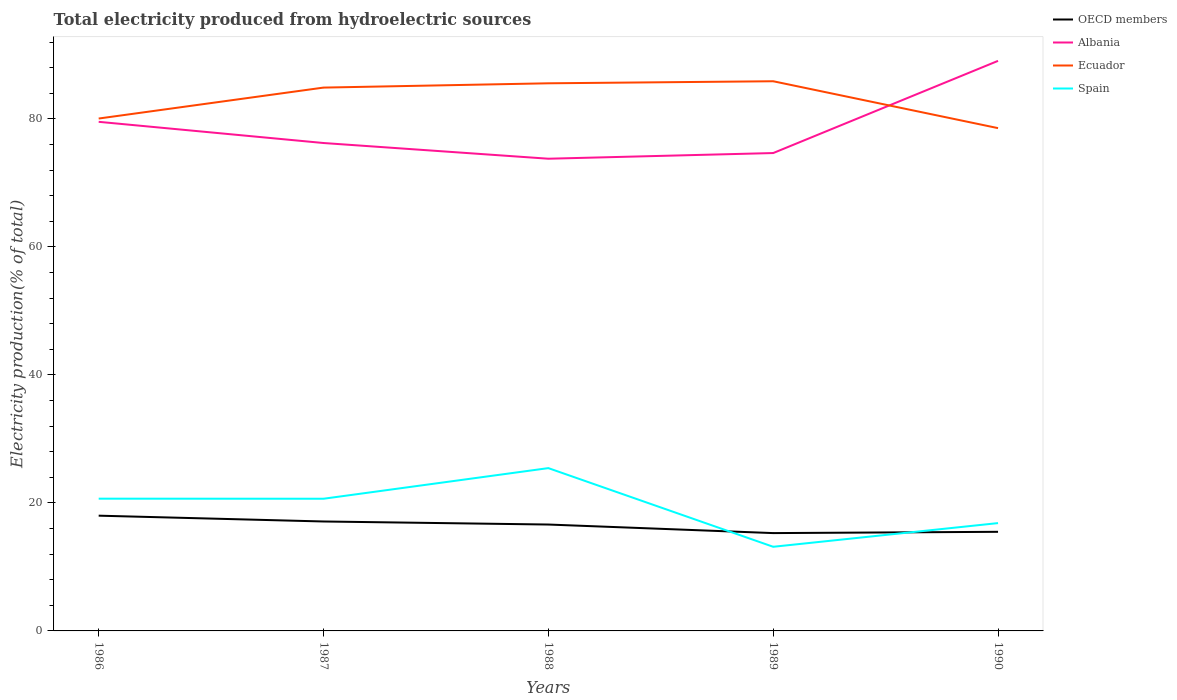Is the number of lines equal to the number of legend labels?
Offer a very short reply. Yes. Across all years, what is the maximum total electricity produced in OECD members?
Offer a very short reply. 15.28. What is the total total electricity produced in Ecuador in the graph?
Your response must be concise. -0.67. What is the difference between the highest and the second highest total electricity produced in Albania?
Offer a very short reply. 15.29. What is the difference between the highest and the lowest total electricity produced in Spain?
Provide a succinct answer. 3. How many lines are there?
Offer a terse response. 4. How many years are there in the graph?
Keep it short and to the point. 5. What is the difference between two consecutive major ticks on the Y-axis?
Keep it short and to the point. 20. Does the graph contain any zero values?
Offer a very short reply. No. Where does the legend appear in the graph?
Your answer should be compact. Top right. How many legend labels are there?
Make the answer very short. 4. How are the legend labels stacked?
Provide a succinct answer. Vertical. What is the title of the graph?
Provide a succinct answer. Total electricity produced from hydroelectric sources. What is the label or title of the X-axis?
Ensure brevity in your answer.  Years. What is the label or title of the Y-axis?
Offer a terse response. Electricity production(% of total). What is the Electricity production(% of total) of OECD members in 1986?
Give a very brief answer. 18.01. What is the Electricity production(% of total) in Albania in 1986?
Give a very brief answer. 79.53. What is the Electricity production(% of total) in Ecuador in 1986?
Give a very brief answer. 80.05. What is the Electricity production(% of total) in Spain in 1986?
Your response must be concise. 20.66. What is the Electricity production(% of total) of OECD members in 1987?
Your answer should be compact. 17.1. What is the Electricity production(% of total) of Albania in 1987?
Keep it short and to the point. 76.22. What is the Electricity production(% of total) of Ecuador in 1987?
Give a very brief answer. 84.88. What is the Electricity production(% of total) of Spain in 1987?
Offer a terse response. 20.65. What is the Electricity production(% of total) of OECD members in 1988?
Ensure brevity in your answer.  16.62. What is the Electricity production(% of total) of Albania in 1988?
Your response must be concise. 73.77. What is the Electricity production(% of total) of Ecuador in 1988?
Offer a terse response. 85.55. What is the Electricity production(% of total) of Spain in 1988?
Your answer should be very brief. 25.43. What is the Electricity production(% of total) in OECD members in 1989?
Provide a short and direct response. 15.28. What is the Electricity production(% of total) of Albania in 1989?
Your answer should be compact. 74.65. What is the Electricity production(% of total) in Ecuador in 1989?
Offer a terse response. 85.87. What is the Electricity production(% of total) in Spain in 1989?
Your response must be concise. 13.14. What is the Electricity production(% of total) in OECD members in 1990?
Provide a short and direct response. 15.48. What is the Electricity production(% of total) in Albania in 1990?
Keep it short and to the point. 89.06. What is the Electricity production(% of total) in Ecuador in 1990?
Your answer should be compact. 78.55. What is the Electricity production(% of total) of Spain in 1990?
Your answer should be very brief. 16.84. Across all years, what is the maximum Electricity production(% of total) of OECD members?
Your response must be concise. 18.01. Across all years, what is the maximum Electricity production(% of total) of Albania?
Offer a terse response. 89.06. Across all years, what is the maximum Electricity production(% of total) of Ecuador?
Give a very brief answer. 85.87. Across all years, what is the maximum Electricity production(% of total) in Spain?
Make the answer very short. 25.43. Across all years, what is the minimum Electricity production(% of total) in OECD members?
Your response must be concise. 15.28. Across all years, what is the minimum Electricity production(% of total) in Albania?
Make the answer very short. 73.77. Across all years, what is the minimum Electricity production(% of total) in Ecuador?
Your answer should be very brief. 78.55. Across all years, what is the minimum Electricity production(% of total) of Spain?
Your answer should be compact. 13.14. What is the total Electricity production(% of total) of OECD members in the graph?
Your answer should be very brief. 82.49. What is the total Electricity production(% of total) in Albania in the graph?
Provide a short and direct response. 393.24. What is the total Electricity production(% of total) in Ecuador in the graph?
Ensure brevity in your answer.  414.9. What is the total Electricity production(% of total) of Spain in the graph?
Ensure brevity in your answer.  96.73. What is the difference between the Electricity production(% of total) of OECD members in 1986 and that in 1987?
Your answer should be very brief. 0.91. What is the difference between the Electricity production(% of total) in Albania in 1986 and that in 1987?
Offer a very short reply. 3.31. What is the difference between the Electricity production(% of total) of Ecuador in 1986 and that in 1987?
Give a very brief answer. -4.83. What is the difference between the Electricity production(% of total) in Spain in 1986 and that in 1987?
Ensure brevity in your answer.  0.01. What is the difference between the Electricity production(% of total) of OECD members in 1986 and that in 1988?
Ensure brevity in your answer.  1.39. What is the difference between the Electricity production(% of total) in Albania in 1986 and that in 1988?
Your response must be concise. 5.76. What is the difference between the Electricity production(% of total) of Ecuador in 1986 and that in 1988?
Your response must be concise. -5.5. What is the difference between the Electricity production(% of total) in Spain in 1986 and that in 1988?
Offer a very short reply. -4.77. What is the difference between the Electricity production(% of total) in OECD members in 1986 and that in 1989?
Provide a succinct answer. 2.72. What is the difference between the Electricity production(% of total) in Albania in 1986 and that in 1989?
Offer a terse response. 4.88. What is the difference between the Electricity production(% of total) in Ecuador in 1986 and that in 1989?
Make the answer very short. -5.82. What is the difference between the Electricity production(% of total) in Spain in 1986 and that in 1989?
Give a very brief answer. 7.52. What is the difference between the Electricity production(% of total) in OECD members in 1986 and that in 1990?
Provide a short and direct response. 2.52. What is the difference between the Electricity production(% of total) of Albania in 1986 and that in 1990?
Provide a short and direct response. -9.52. What is the difference between the Electricity production(% of total) in Ecuador in 1986 and that in 1990?
Give a very brief answer. 1.5. What is the difference between the Electricity production(% of total) of Spain in 1986 and that in 1990?
Your answer should be compact. 3.82. What is the difference between the Electricity production(% of total) of OECD members in 1987 and that in 1988?
Your answer should be compact. 0.48. What is the difference between the Electricity production(% of total) of Albania in 1987 and that in 1988?
Your answer should be very brief. 2.45. What is the difference between the Electricity production(% of total) in Ecuador in 1987 and that in 1988?
Offer a terse response. -0.67. What is the difference between the Electricity production(% of total) of Spain in 1987 and that in 1988?
Offer a terse response. -4.78. What is the difference between the Electricity production(% of total) of OECD members in 1987 and that in 1989?
Offer a very short reply. 1.81. What is the difference between the Electricity production(% of total) in Albania in 1987 and that in 1989?
Your answer should be compact. 1.57. What is the difference between the Electricity production(% of total) in Ecuador in 1987 and that in 1989?
Ensure brevity in your answer.  -0.99. What is the difference between the Electricity production(% of total) in Spain in 1987 and that in 1989?
Your answer should be compact. 7.51. What is the difference between the Electricity production(% of total) of OECD members in 1987 and that in 1990?
Offer a very short reply. 1.61. What is the difference between the Electricity production(% of total) of Albania in 1987 and that in 1990?
Provide a succinct answer. -12.83. What is the difference between the Electricity production(% of total) of Ecuador in 1987 and that in 1990?
Offer a very short reply. 6.33. What is the difference between the Electricity production(% of total) of Spain in 1987 and that in 1990?
Provide a short and direct response. 3.81. What is the difference between the Electricity production(% of total) in OECD members in 1988 and that in 1989?
Provide a succinct answer. 1.34. What is the difference between the Electricity production(% of total) of Albania in 1988 and that in 1989?
Offer a terse response. -0.88. What is the difference between the Electricity production(% of total) of Ecuador in 1988 and that in 1989?
Give a very brief answer. -0.32. What is the difference between the Electricity production(% of total) of Spain in 1988 and that in 1989?
Offer a terse response. 12.29. What is the difference between the Electricity production(% of total) of OECD members in 1988 and that in 1990?
Your response must be concise. 1.14. What is the difference between the Electricity production(% of total) of Albania in 1988 and that in 1990?
Offer a very short reply. -15.29. What is the difference between the Electricity production(% of total) in Ecuador in 1988 and that in 1990?
Ensure brevity in your answer.  7. What is the difference between the Electricity production(% of total) in Spain in 1988 and that in 1990?
Give a very brief answer. 8.59. What is the difference between the Electricity production(% of total) in OECD members in 1989 and that in 1990?
Ensure brevity in your answer.  -0.2. What is the difference between the Electricity production(% of total) in Albania in 1989 and that in 1990?
Your answer should be compact. -14.4. What is the difference between the Electricity production(% of total) in Ecuador in 1989 and that in 1990?
Offer a very short reply. 7.33. What is the difference between the Electricity production(% of total) of Spain in 1989 and that in 1990?
Provide a short and direct response. -3.7. What is the difference between the Electricity production(% of total) of OECD members in 1986 and the Electricity production(% of total) of Albania in 1987?
Make the answer very short. -58.22. What is the difference between the Electricity production(% of total) of OECD members in 1986 and the Electricity production(% of total) of Ecuador in 1987?
Your answer should be compact. -66.88. What is the difference between the Electricity production(% of total) of OECD members in 1986 and the Electricity production(% of total) of Spain in 1987?
Your response must be concise. -2.64. What is the difference between the Electricity production(% of total) of Albania in 1986 and the Electricity production(% of total) of Ecuador in 1987?
Provide a succinct answer. -5.35. What is the difference between the Electricity production(% of total) of Albania in 1986 and the Electricity production(% of total) of Spain in 1987?
Provide a short and direct response. 58.88. What is the difference between the Electricity production(% of total) of Ecuador in 1986 and the Electricity production(% of total) of Spain in 1987?
Give a very brief answer. 59.4. What is the difference between the Electricity production(% of total) of OECD members in 1986 and the Electricity production(% of total) of Albania in 1988?
Ensure brevity in your answer.  -55.76. What is the difference between the Electricity production(% of total) in OECD members in 1986 and the Electricity production(% of total) in Ecuador in 1988?
Ensure brevity in your answer.  -67.55. What is the difference between the Electricity production(% of total) of OECD members in 1986 and the Electricity production(% of total) of Spain in 1988?
Your answer should be compact. -7.43. What is the difference between the Electricity production(% of total) in Albania in 1986 and the Electricity production(% of total) in Ecuador in 1988?
Your answer should be compact. -6.02. What is the difference between the Electricity production(% of total) of Albania in 1986 and the Electricity production(% of total) of Spain in 1988?
Provide a short and direct response. 54.1. What is the difference between the Electricity production(% of total) in Ecuador in 1986 and the Electricity production(% of total) in Spain in 1988?
Keep it short and to the point. 54.61. What is the difference between the Electricity production(% of total) in OECD members in 1986 and the Electricity production(% of total) in Albania in 1989?
Your answer should be very brief. -56.65. What is the difference between the Electricity production(% of total) of OECD members in 1986 and the Electricity production(% of total) of Ecuador in 1989?
Keep it short and to the point. -67.87. What is the difference between the Electricity production(% of total) of OECD members in 1986 and the Electricity production(% of total) of Spain in 1989?
Offer a terse response. 4.86. What is the difference between the Electricity production(% of total) of Albania in 1986 and the Electricity production(% of total) of Ecuador in 1989?
Offer a very short reply. -6.34. What is the difference between the Electricity production(% of total) in Albania in 1986 and the Electricity production(% of total) in Spain in 1989?
Make the answer very short. 66.39. What is the difference between the Electricity production(% of total) of Ecuador in 1986 and the Electricity production(% of total) of Spain in 1989?
Your answer should be compact. 66.9. What is the difference between the Electricity production(% of total) of OECD members in 1986 and the Electricity production(% of total) of Albania in 1990?
Provide a succinct answer. -71.05. What is the difference between the Electricity production(% of total) in OECD members in 1986 and the Electricity production(% of total) in Ecuador in 1990?
Provide a succinct answer. -60.54. What is the difference between the Electricity production(% of total) of OECD members in 1986 and the Electricity production(% of total) of Spain in 1990?
Ensure brevity in your answer.  1.16. What is the difference between the Electricity production(% of total) in Albania in 1986 and the Electricity production(% of total) in Ecuador in 1990?
Offer a very short reply. 0.99. What is the difference between the Electricity production(% of total) of Albania in 1986 and the Electricity production(% of total) of Spain in 1990?
Provide a succinct answer. 62.69. What is the difference between the Electricity production(% of total) of Ecuador in 1986 and the Electricity production(% of total) of Spain in 1990?
Ensure brevity in your answer.  63.2. What is the difference between the Electricity production(% of total) in OECD members in 1987 and the Electricity production(% of total) in Albania in 1988?
Your response must be concise. -56.67. What is the difference between the Electricity production(% of total) of OECD members in 1987 and the Electricity production(% of total) of Ecuador in 1988?
Offer a terse response. -68.46. What is the difference between the Electricity production(% of total) in OECD members in 1987 and the Electricity production(% of total) in Spain in 1988?
Provide a succinct answer. -8.34. What is the difference between the Electricity production(% of total) in Albania in 1987 and the Electricity production(% of total) in Ecuador in 1988?
Your answer should be compact. -9.33. What is the difference between the Electricity production(% of total) of Albania in 1987 and the Electricity production(% of total) of Spain in 1988?
Keep it short and to the point. 50.79. What is the difference between the Electricity production(% of total) in Ecuador in 1987 and the Electricity production(% of total) in Spain in 1988?
Your response must be concise. 59.45. What is the difference between the Electricity production(% of total) of OECD members in 1987 and the Electricity production(% of total) of Albania in 1989?
Offer a very short reply. -57.56. What is the difference between the Electricity production(% of total) of OECD members in 1987 and the Electricity production(% of total) of Ecuador in 1989?
Provide a short and direct response. -68.78. What is the difference between the Electricity production(% of total) of OECD members in 1987 and the Electricity production(% of total) of Spain in 1989?
Keep it short and to the point. 3.95. What is the difference between the Electricity production(% of total) in Albania in 1987 and the Electricity production(% of total) in Ecuador in 1989?
Make the answer very short. -9.65. What is the difference between the Electricity production(% of total) in Albania in 1987 and the Electricity production(% of total) in Spain in 1989?
Keep it short and to the point. 63.08. What is the difference between the Electricity production(% of total) of Ecuador in 1987 and the Electricity production(% of total) of Spain in 1989?
Make the answer very short. 71.74. What is the difference between the Electricity production(% of total) of OECD members in 1987 and the Electricity production(% of total) of Albania in 1990?
Ensure brevity in your answer.  -71.96. What is the difference between the Electricity production(% of total) in OECD members in 1987 and the Electricity production(% of total) in Ecuador in 1990?
Ensure brevity in your answer.  -61.45. What is the difference between the Electricity production(% of total) in OECD members in 1987 and the Electricity production(% of total) in Spain in 1990?
Provide a short and direct response. 0.25. What is the difference between the Electricity production(% of total) of Albania in 1987 and the Electricity production(% of total) of Ecuador in 1990?
Provide a short and direct response. -2.32. What is the difference between the Electricity production(% of total) of Albania in 1987 and the Electricity production(% of total) of Spain in 1990?
Ensure brevity in your answer.  59.38. What is the difference between the Electricity production(% of total) in Ecuador in 1987 and the Electricity production(% of total) in Spain in 1990?
Offer a terse response. 68.04. What is the difference between the Electricity production(% of total) in OECD members in 1988 and the Electricity production(% of total) in Albania in 1989?
Your answer should be compact. -58.03. What is the difference between the Electricity production(% of total) in OECD members in 1988 and the Electricity production(% of total) in Ecuador in 1989?
Keep it short and to the point. -69.25. What is the difference between the Electricity production(% of total) in OECD members in 1988 and the Electricity production(% of total) in Spain in 1989?
Ensure brevity in your answer.  3.48. What is the difference between the Electricity production(% of total) of Albania in 1988 and the Electricity production(% of total) of Ecuador in 1989?
Make the answer very short. -12.1. What is the difference between the Electricity production(% of total) in Albania in 1988 and the Electricity production(% of total) in Spain in 1989?
Your response must be concise. 60.63. What is the difference between the Electricity production(% of total) of Ecuador in 1988 and the Electricity production(% of total) of Spain in 1989?
Your response must be concise. 72.41. What is the difference between the Electricity production(% of total) of OECD members in 1988 and the Electricity production(% of total) of Albania in 1990?
Provide a short and direct response. -72.44. What is the difference between the Electricity production(% of total) in OECD members in 1988 and the Electricity production(% of total) in Ecuador in 1990?
Ensure brevity in your answer.  -61.93. What is the difference between the Electricity production(% of total) of OECD members in 1988 and the Electricity production(% of total) of Spain in 1990?
Offer a terse response. -0.22. What is the difference between the Electricity production(% of total) in Albania in 1988 and the Electricity production(% of total) in Ecuador in 1990?
Your answer should be very brief. -4.78. What is the difference between the Electricity production(% of total) of Albania in 1988 and the Electricity production(% of total) of Spain in 1990?
Your answer should be very brief. 56.93. What is the difference between the Electricity production(% of total) in Ecuador in 1988 and the Electricity production(% of total) in Spain in 1990?
Your answer should be compact. 68.71. What is the difference between the Electricity production(% of total) of OECD members in 1989 and the Electricity production(% of total) of Albania in 1990?
Offer a very short reply. -73.77. What is the difference between the Electricity production(% of total) in OECD members in 1989 and the Electricity production(% of total) in Ecuador in 1990?
Make the answer very short. -63.27. What is the difference between the Electricity production(% of total) of OECD members in 1989 and the Electricity production(% of total) of Spain in 1990?
Offer a terse response. -1.56. What is the difference between the Electricity production(% of total) in Albania in 1989 and the Electricity production(% of total) in Ecuador in 1990?
Your response must be concise. -3.89. What is the difference between the Electricity production(% of total) in Albania in 1989 and the Electricity production(% of total) in Spain in 1990?
Your answer should be compact. 57.81. What is the difference between the Electricity production(% of total) in Ecuador in 1989 and the Electricity production(% of total) in Spain in 1990?
Ensure brevity in your answer.  69.03. What is the average Electricity production(% of total) in OECD members per year?
Offer a terse response. 16.5. What is the average Electricity production(% of total) in Albania per year?
Make the answer very short. 78.65. What is the average Electricity production(% of total) of Ecuador per year?
Offer a very short reply. 82.98. What is the average Electricity production(% of total) in Spain per year?
Ensure brevity in your answer.  19.35. In the year 1986, what is the difference between the Electricity production(% of total) in OECD members and Electricity production(% of total) in Albania?
Provide a short and direct response. -61.53. In the year 1986, what is the difference between the Electricity production(% of total) in OECD members and Electricity production(% of total) in Ecuador?
Give a very brief answer. -62.04. In the year 1986, what is the difference between the Electricity production(% of total) in OECD members and Electricity production(% of total) in Spain?
Ensure brevity in your answer.  -2.66. In the year 1986, what is the difference between the Electricity production(% of total) of Albania and Electricity production(% of total) of Ecuador?
Your response must be concise. -0.51. In the year 1986, what is the difference between the Electricity production(% of total) in Albania and Electricity production(% of total) in Spain?
Your answer should be compact. 58.87. In the year 1986, what is the difference between the Electricity production(% of total) of Ecuador and Electricity production(% of total) of Spain?
Offer a terse response. 59.39. In the year 1987, what is the difference between the Electricity production(% of total) in OECD members and Electricity production(% of total) in Albania?
Your answer should be very brief. -59.13. In the year 1987, what is the difference between the Electricity production(% of total) in OECD members and Electricity production(% of total) in Ecuador?
Your answer should be very brief. -67.78. In the year 1987, what is the difference between the Electricity production(% of total) in OECD members and Electricity production(% of total) in Spain?
Make the answer very short. -3.55. In the year 1987, what is the difference between the Electricity production(% of total) in Albania and Electricity production(% of total) in Ecuador?
Your answer should be very brief. -8.66. In the year 1987, what is the difference between the Electricity production(% of total) in Albania and Electricity production(% of total) in Spain?
Your answer should be compact. 55.57. In the year 1987, what is the difference between the Electricity production(% of total) of Ecuador and Electricity production(% of total) of Spain?
Provide a succinct answer. 64.23. In the year 1988, what is the difference between the Electricity production(% of total) in OECD members and Electricity production(% of total) in Albania?
Keep it short and to the point. -57.15. In the year 1988, what is the difference between the Electricity production(% of total) of OECD members and Electricity production(% of total) of Ecuador?
Provide a short and direct response. -68.93. In the year 1988, what is the difference between the Electricity production(% of total) in OECD members and Electricity production(% of total) in Spain?
Offer a very short reply. -8.81. In the year 1988, what is the difference between the Electricity production(% of total) of Albania and Electricity production(% of total) of Ecuador?
Your response must be concise. -11.78. In the year 1988, what is the difference between the Electricity production(% of total) of Albania and Electricity production(% of total) of Spain?
Your answer should be very brief. 48.34. In the year 1988, what is the difference between the Electricity production(% of total) of Ecuador and Electricity production(% of total) of Spain?
Give a very brief answer. 60.12. In the year 1989, what is the difference between the Electricity production(% of total) in OECD members and Electricity production(% of total) in Albania?
Provide a succinct answer. -59.37. In the year 1989, what is the difference between the Electricity production(% of total) in OECD members and Electricity production(% of total) in Ecuador?
Make the answer very short. -70.59. In the year 1989, what is the difference between the Electricity production(% of total) of OECD members and Electricity production(% of total) of Spain?
Ensure brevity in your answer.  2.14. In the year 1989, what is the difference between the Electricity production(% of total) in Albania and Electricity production(% of total) in Ecuador?
Provide a succinct answer. -11.22. In the year 1989, what is the difference between the Electricity production(% of total) in Albania and Electricity production(% of total) in Spain?
Provide a succinct answer. 61.51. In the year 1989, what is the difference between the Electricity production(% of total) in Ecuador and Electricity production(% of total) in Spain?
Provide a succinct answer. 72.73. In the year 1990, what is the difference between the Electricity production(% of total) in OECD members and Electricity production(% of total) in Albania?
Your answer should be very brief. -73.57. In the year 1990, what is the difference between the Electricity production(% of total) of OECD members and Electricity production(% of total) of Ecuador?
Your answer should be very brief. -63.06. In the year 1990, what is the difference between the Electricity production(% of total) of OECD members and Electricity production(% of total) of Spain?
Give a very brief answer. -1.36. In the year 1990, what is the difference between the Electricity production(% of total) in Albania and Electricity production(% of total) in Ecuador?
Provide a short and direct response. 10.51. In the year 1990, what is the difference between the Electricity production(% of total) of Albania and Electricity production(% of total) of Spain?
Provide a short and direct response. 72.21. In the year 1990, what is the difference between the Electricity production(% of total) in Ecuador and Electricity production(% of total) in Spain?
Your response must be concise. 61.7. What is the ratio of the Electricity production(% of total) of OECD members in 1986 to that in 1987?
Give a very brief answer. 1.05. What is the ratio of the Electricity production(% of total) of Albania in 1986 to that in 1987?
Make the answer very short. 1.04. What is the ratio of the Electricity production(% of total) in Ecuador in 1986 to that in 1987?
Offer a very short reply. 0.94. What is the ratio of the Electricity production(% of total) of OECD members in 1986 to that in 1988?
Offer a very short reply. 1.08. What is the ratio of the Electricity production(% of total) of Albania in 1986 to that in 1988?
Give a very brief answer. 1.08. What is the ratio of the Electricity production(% of total) of Ecuador in 1986 to that in 1988?
Your answer should be very brief. 0.94. What is the ratio of the Electricity production(% of total) of Spain in 1986 to that in 1988?
Provide a short and direct response. 0.81. What is the ratio of the Electricity production(% of total) of OECD members in 1986 to that in 1989?
Ensure brevity in your answer.  1.18. What is the ratio of the Electricity production(% of total) in Albania in 1986 to that in 1989?
Your answer should be compact. 1.07. What is the ratio of the Electricity production(% of total) of Ecuador in 1986 to that in 1989?
Provide a short and direct response. 0.93. What is the ratio of the Electricity production(% of total) in Spain in 1986 to that in 1989?
Offer a very short reply. 1.57. What is the ratio of the Electricity production(% of total) in OECD members in 1986 to that in 1990?
Make the answer very short. 1.16. What is the ratio of the Electricity production(% of total) in Albania in 1986 to that in 1990?
Provide a succinct answer. 0.89. What is the ratio of the Electricity production(% of total) in Ecuador in 1986 to that in 1990?
Ensure brevity in your answer.  1.02. What is the ratio of the Electricity production(% of total) in Spain in 1986 to that in 1990?
Offer a terse response. 1.23. What is the ratio of the Electricity production(% of total) of OECD members in 1987 to that in 1988?
Ensure brevity in your answer.  1.03. What is the ratio of the Electricity production(% of total) of Albania in 1987 to that in 1988?
Give a very brief answer. 1.03. What is the ratio of the Electricity production(% of total) in Spain in 1987 to that in 1988?
Your response must be concise. 0.81. What is the ratio of the Electricity production(% of total) in OECD members in 1987 to that in 1989?
Offer a very short reply. 1.12. What is the ratio of the Electricity production(% of total) of Albania in 1987 to that in 1989?
Give a very brief answer. 1.02. What is the ratio of the Electricity production(% of total) of Spain in 1987 to that in 1989?
Your answer should be compact. 1.57. What is the ratio of the Electricity production(% of total) in OECD members in 1987 to that in 1990?
Provide a short and direct response. 1.1. What is the ratio of the Electricity production(% of total) in Albania in 1987 to that in 1990?
Offer a very short reply. 0.86. What is the ratio of the Electricity production(% of total) of Ecuador in 1987 to that in 1990?
Offer a very short reply. 1.08. What is the ratio of the Electricity production(% of total) in Spain in 1987 to that in 1990?
Offer a terse response. 1.23. What is the ratio of the Electricity production(% of total) of OECD members in 1988 to that in 1989?
Provide a short and direct response. 1.09. What is the ratio of the Electricity production(% of total) of Albania in 1988 to that in 1989?
Offer a very short reply. 0.99. What is the ratio of the Electricity production(% of total) in Spain in 1988 to that in 1989?
Offer a terse response. 1.93. What is the ratio of the Electricity production(% of total) of OECD members in 1988 to that in 1990?
Give a very brief answer. 1.07. What is the ratio of the Electricity production(% of total) in Albania in 1988 to that in 1990?
Your answer should be compact. 0.83. What is the ratio of the Electricity production(% of total) of Ecuador in 1988 to that in 1990?
Your answer should be compact. 1.09. What is the ratio of the Electricity production(% of total) in Spain in 1988 to that in 1990?
Offer a very short reply. 1.51. What is the ratio of the Electricity production(% of total) in Albania in 1989 to that in 1990?
Offer a terse response. 0.84. What is the ratio of the Electricity production(% of total) of Ecuador in 1989 to that in 1990?
Give a very brief answer. 1.09. What is the ratio of the Electricity production(% of total) of Spain in 1989 to that in 1990?
Keep it short and to the point. 0.78. What is the difference between the highest and the second highest Electricity production(% of total) in OECD members?
Provide a short and direct response. 0.91. What is the difference between the highest and the second highest Electricity production(% of total) in Albania?
Your answer should be compact. 9.52. What is the difference between the highest and the second highest Electricity production(% of total) of Ecuador?
Provide a short and direct response. 0.32. What is the difference between the highest and the second highest Electricity production(% of total) in Spain?
Keep it short and to the point. 4.77. What is the difference between the highest and the lowest Electricity production(% of total) in OECD members?
Ensure brevity in your answer.  2.72. What is the difference between the highest and the lowest Electricity production(% of total) in Albania?
Offer a very short reply. 15.29. What is the difference between the highest and the lowest Electricity production(% of total) of Ecuador?
Keep it short and to the point. 7.33. What is the difference between the highest and the lowest Electricity production(% of total) in Spain?
Keep it short and to the point. 12.29. 